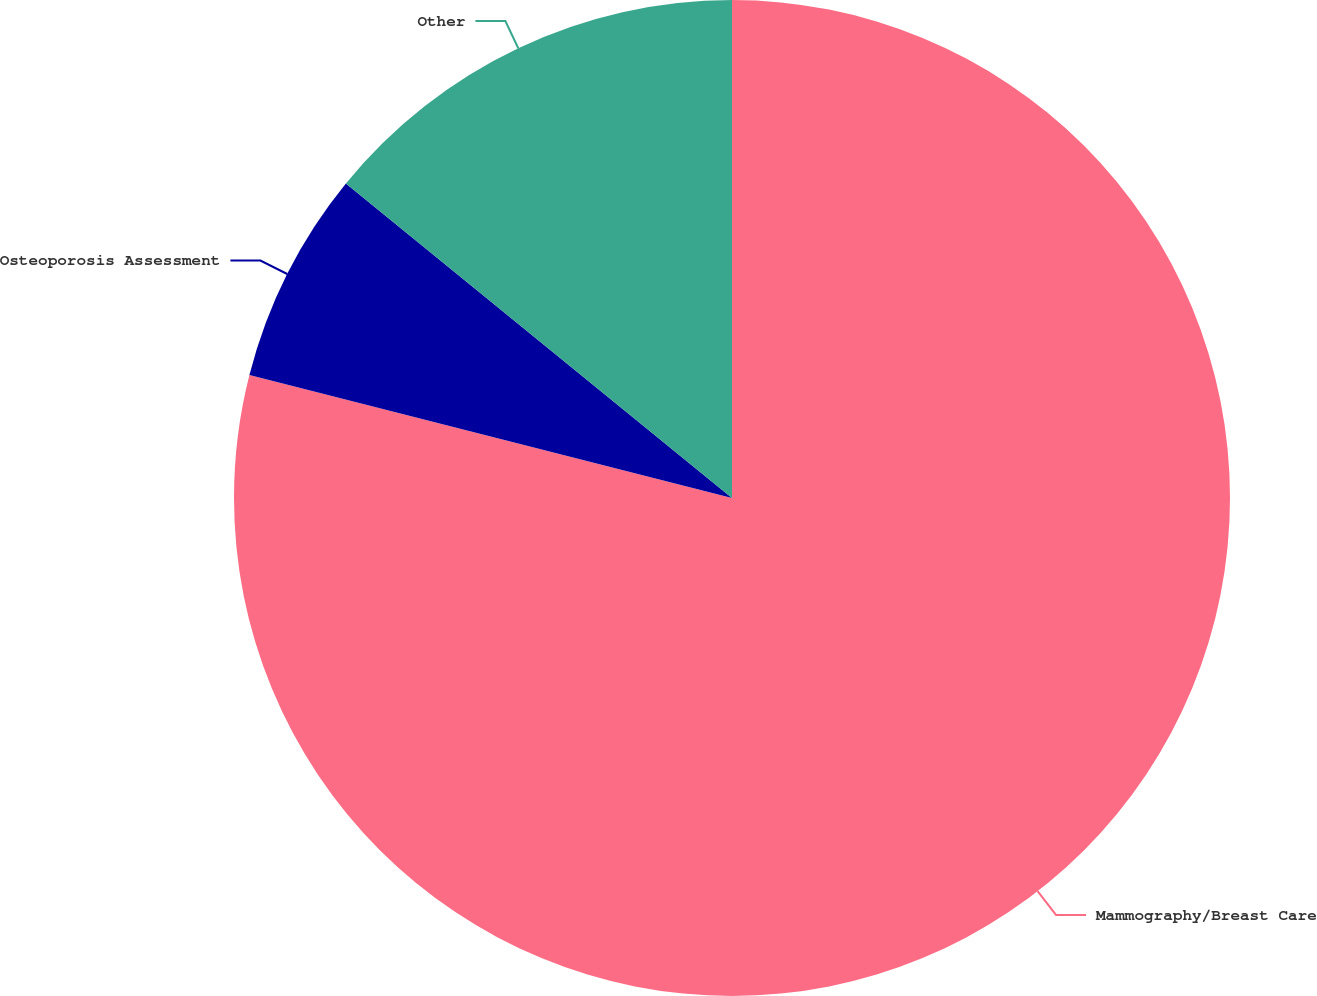<chart> <loc_0><loc_0><loc_500><loc_500><pie_chart><fcel>Mammography/Breast Care<fcel>Osteoporosis Assessment<fcel>Other<nl><fcel>78.97%<fcel>6.91%<fcel>14.12%<nl></chart> 